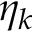Convert formula to latex. <formula><loc_0><loc_0><loc_500><loc_500>\eta _ { k }</formula> 